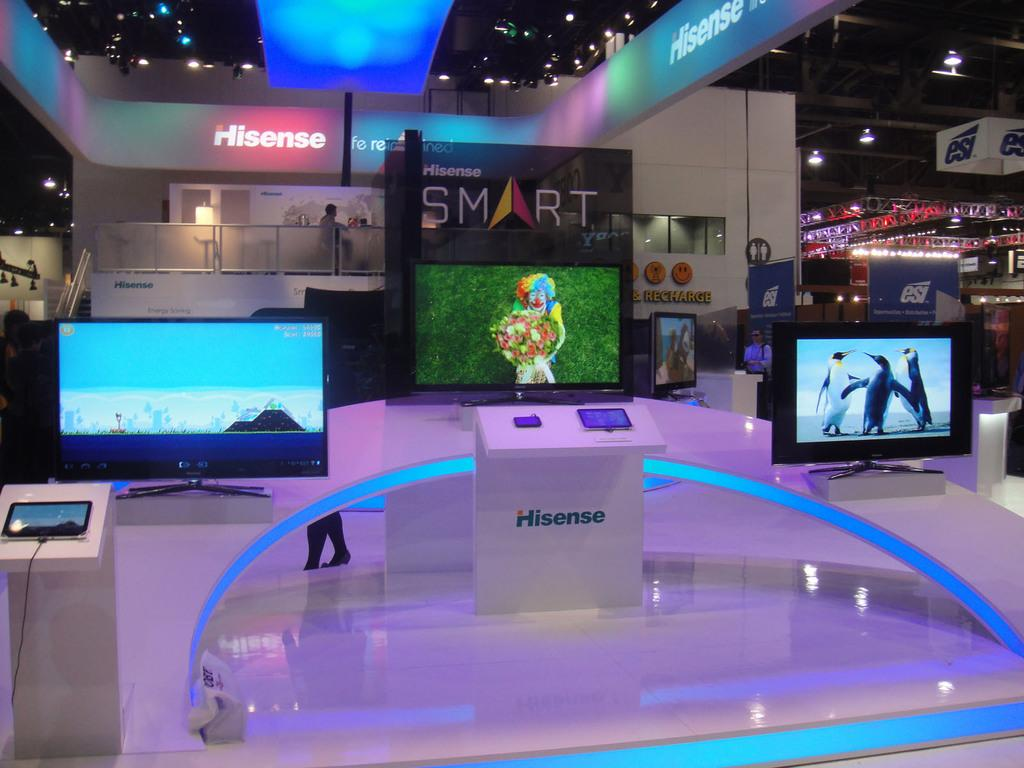Provide a one-sentence caption for the provided image. a sign that has the word smart on it in a room. 